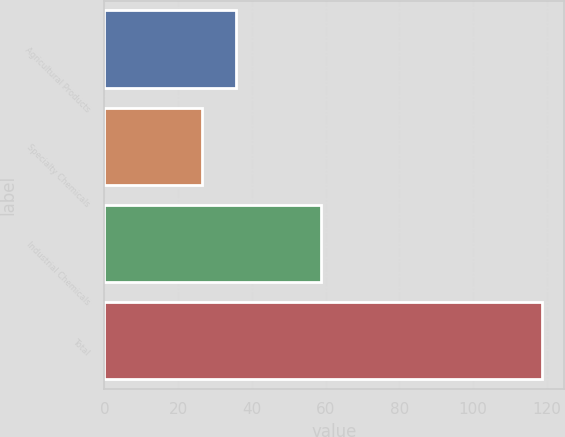<chart> <loc_0><loc_0><loc_500><loc_500><bar_chart><fcel>Agricultural Products<fcel>Specialty Chemicals<fcel>Industrial Chemicals<fcel>Total<nl><fcel>35.73<fcel>26.5<fcel>58.7<fcel>118.8<nl></chart> 